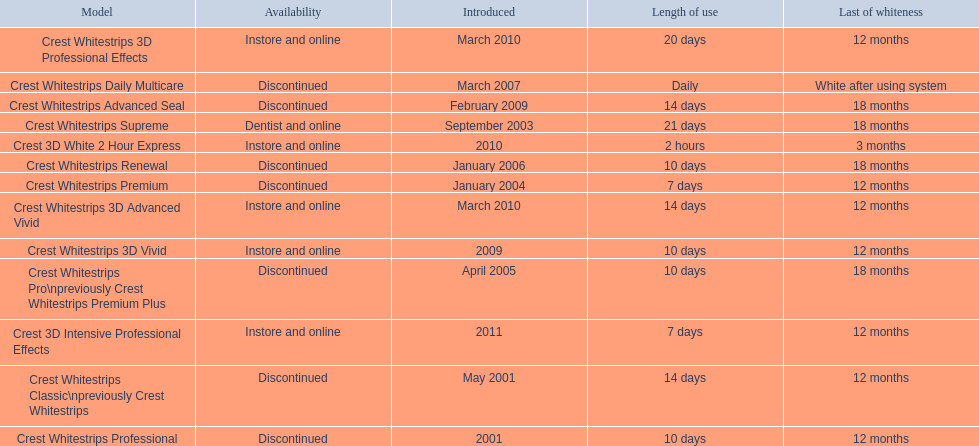Which of these products are discontinued? Crest Whitestrips Classic\npreviously Crest Whitestrips, Crest Whitestrips Professional, Crest Whitestrips Premium, Crest Whitestrips Pro\npreviously Crest Whitestrips Premium Plus, Crest Whitestrips Renewal, Crest Whitestrips Daily Multicare, Crest Whitestrips Advanced Seal. Which of these products have a 14 day length of use? Crest Whitestrips Classic\npreviously Crest Whitestrips, Crest Whitestrips Advanced Seal. Parse the full table in json format. {'header': ['Model', 'Availability', 'Introduced', 'Length of use', 'Last of whiteness'], 'rows': [['Crest Whitestrips 3D Professional Effects', 'Instore and online', 'March 2010', '20 days', '12 months'], ['Crest Whitestrips Daily Multicare', 'Discontinued', 'March 2007', 'Daily', 'White after using system'], ['Crest Whitestrips Advanced Seal', 'Discontinued', 'February 2009', '14 days', '18 months'], ['Crest Whitestrips Supreme', 'Dentist and online', 'September 2003', '21 days', '18 months'], ['Crest 3D White 2 Hour Express', 'Instore and online', '2010', '2 hours', '3 months'], ['Crest Whitestrips Renewal', 'Discontinued', 'January 2006', '10 days', '18 months'], ['Crest Whitestrips Premium', 'Discontinued', 'January 2004', '7 days', '12 months'], ['Crest Whitestrips 3D Advanced Vivid', 'Instore and online', 'March 2010', '14 days', '12 months'], ['Crest Whitestrips 3D Vivid', 'Instore and online', '2009', '10 days', '12 months'], ['Crest Whitestrips Pro\\npreviously Crest Whitestrips Premium Plus', 'Discontinued', 'April 2005', '10 days', '18 months'], ['Crest 3D Intensive Professional Effects', 'Instore and online', '2011', '7 days', '12 months'], ['Crest Whitestrips Classic\\npreviously Crest Whitestrips', 'Discontinued', 'May 2001', '14 days', '12 months'], ['Crest Whitestrips Professional', 'Discontinued', '2001', '10 days', '12 months']]} Which of these products was introduced in 2009? Crest Whitestrips Advanced Seal. 